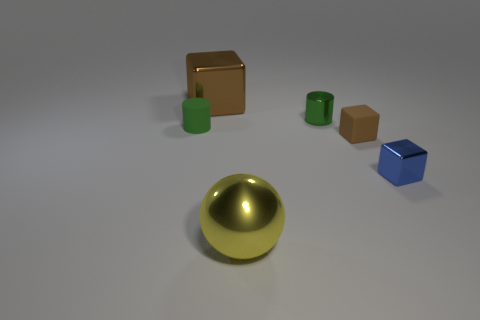Is there a brown sphere made of the same material as the big block?
Your response must be concise. No. There is a brown metal object that is the same shape as the blue metallic object; what size is it?
Your answer should be very brief. Large. Is the number of tiny green things that are to the left of the green metallic cylinder the same as the number of blue cubes?
Offer a very short reply. Yes. Is the shape of the tiny metal thing that is behind the small brown rubber thing the same as  the large brown thing?
Keep it short and to the point. No. What shape is the green rubber object?
Your answer should be very brief. Cylinder. What material is the small green object that is right of the big thing in front of the matte object right of the big block?
Make the answer very short. Metal. There is a small thing that is the same color as the small rubber cylinder; what is it made of?
Offer a terse response. Metal. What number of things are either big brown matte cylinders or green things?
Offer a terse response. 2. Do the green thing to the left of the large brown shiny thing and the yellow ball have the same material?
Keep it short and to the point. No. How many things are brown cubes that are to the right of the large yellow shiny object or blue blocks?
Keep it short and to the point. 2. 